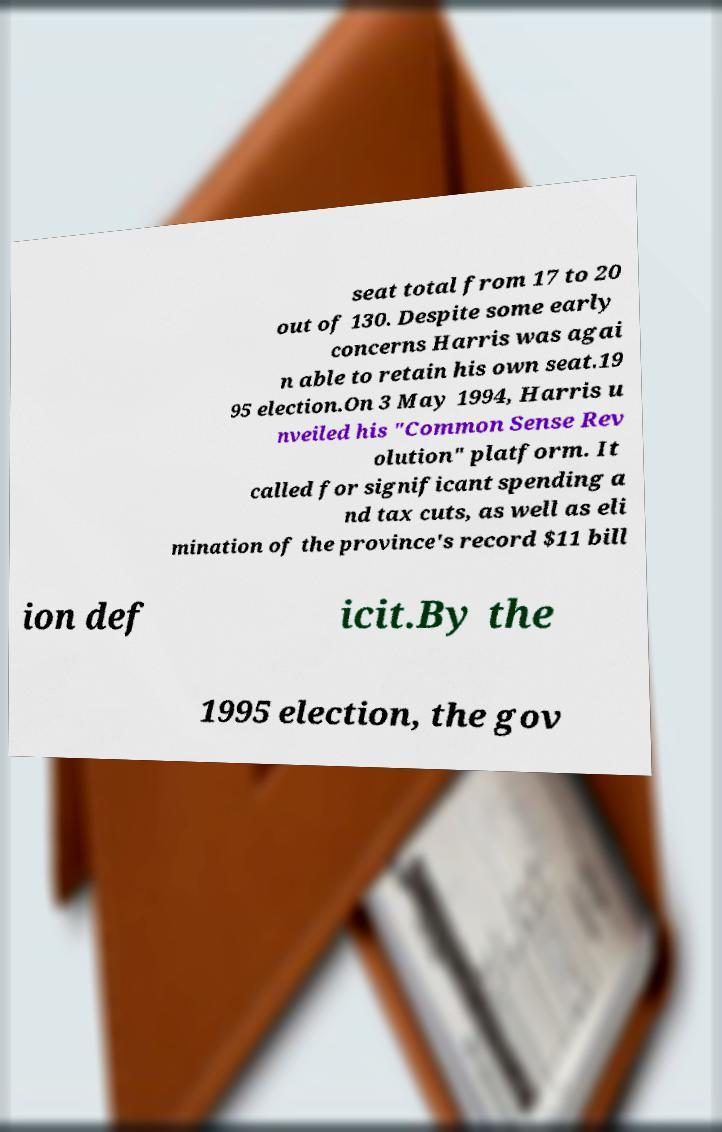Can you accurately transcribe the text from the provided image for me? seat total from 17 to 20 out of 130. Despite some early concerns Harris was agai n able to retain his own seat.19 95 election.On 3 May 1994, Harris u nveiled his "Common Sense Rev olution" platform. It called for significant spending a nd tax cuts, as well as eli mination of the province's record $11 bill ion def icit.By the 1995 election, the gov 